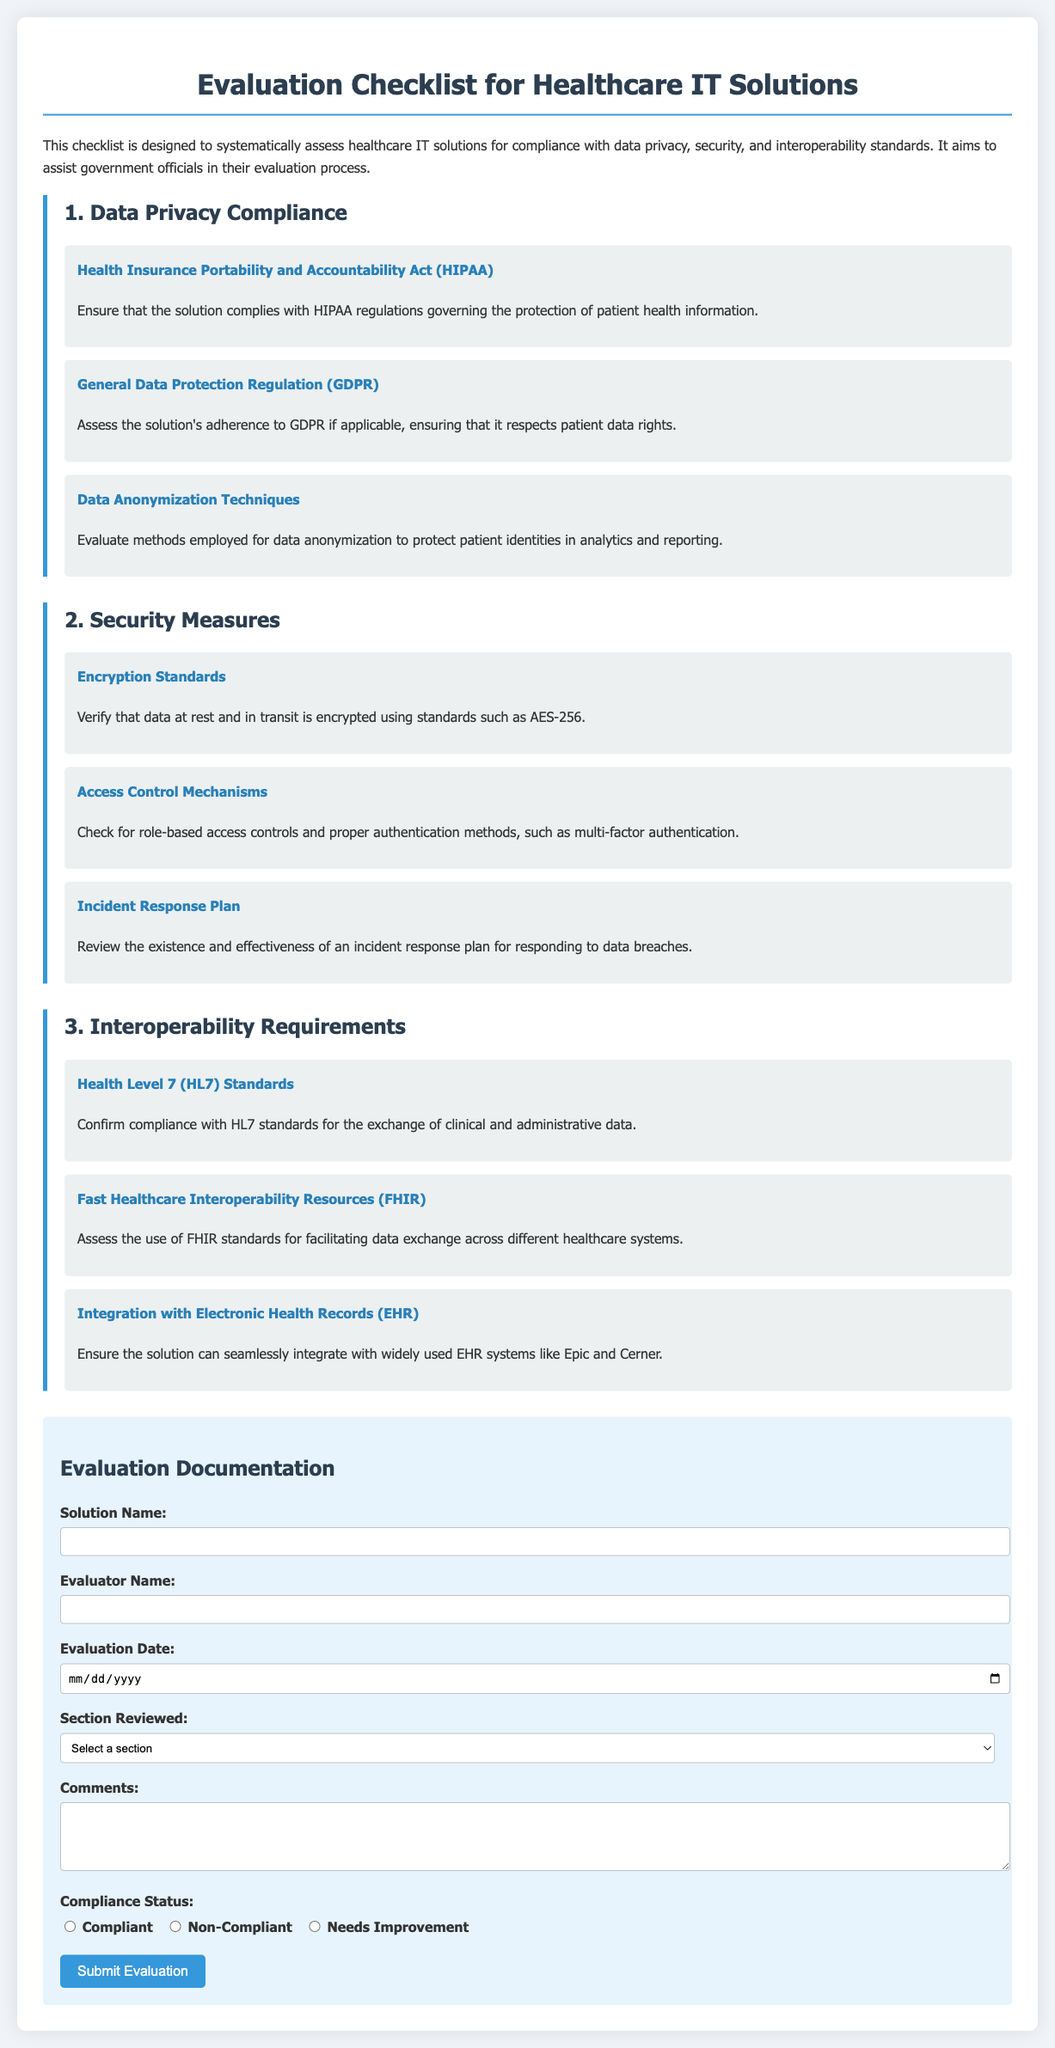What is the first section of the document? The first section of the document is about Data Privacy Compliance, as indicated by the headings.
Answer: Data Privacy Compliance How many requirements are listed under Security Measures? The document includes three requirements listed under the Security Measures section.
Answer: 3 What encryption standard is mentioned for data protection? The document specifies that encryption should use standards such as AES-256 for data protection.
Answer: AES-256 Which regulation requires compliance regarding patient health information? The document references the Health Insurance Portability and Accountability Act in relation to patient health information protection.
Answer: HIPAA What does FHIR stand for in the context of interoperability? The abbreviation FHIR stands for Fast Healthcare Interoperability Resources, as noted in the Interoperability Requirements section.
Answer: Fast Healthcare Interoperability Resources What is required in the Compliance Status section of the evaluation form? The Compliance Status section requires evaluators to select options such as Compliant, Non-Compliant, or Needs Improvement.
Answer: Compliant, Non-Compliant, Needs Improvement What form type is provided for Evaluation Documentation? The document includes a form type specifically designed for collect evaluation documentation related to healthcare IT solutions.
Answer: Form What is the purpose of the checklist in the document? The checklist is designed to systematically assess healthcare IT solutions for compliance with various standards and regulations.
Answer: Assess compliance Who should complete the evaluation form according to the document? The evaluation form should be completed by an evaluator, as indicated in the form fields.
Answer: Evaluator 